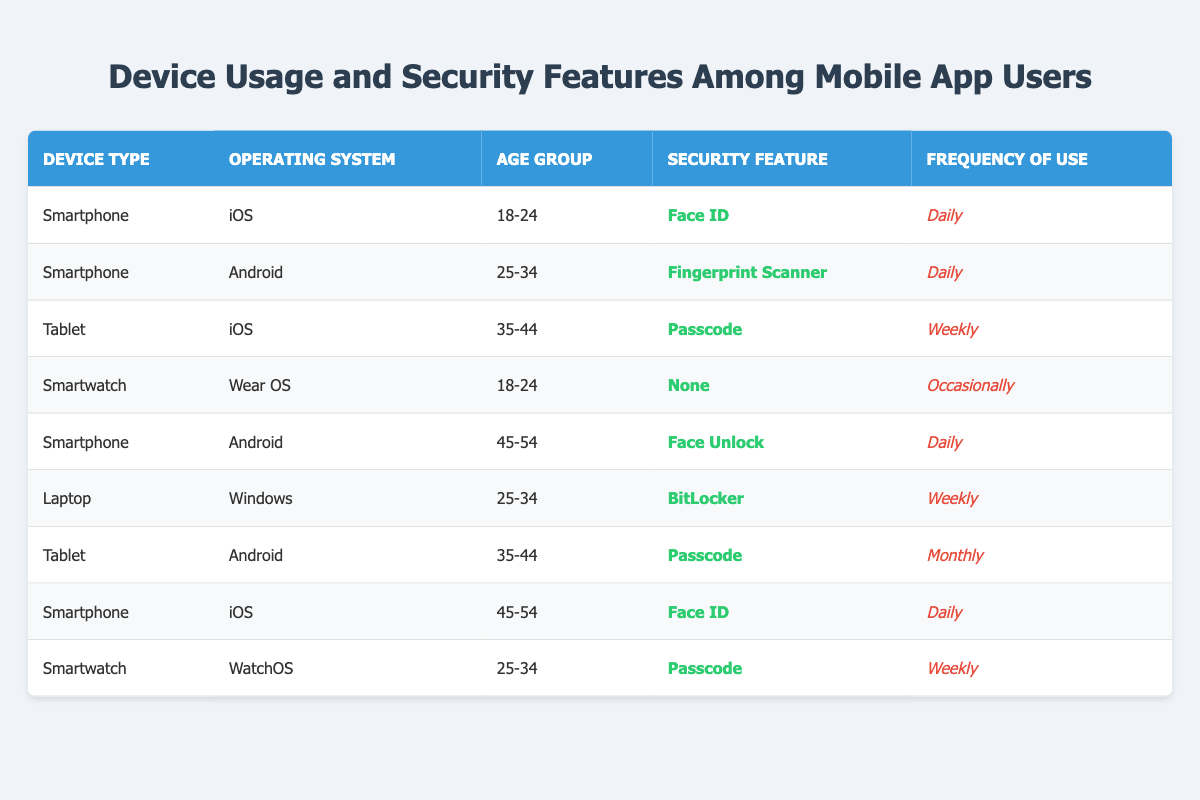What security feature is used by users aged 18-24 with smartphones running iOS? The table shows that in the row where the device type is "Smartphone," operating system is "iOS," and age group is "18-24," the security feature used is "Face ID."
Answer: Face ID How frequently do users aged 35-44 with tablets running iOS utilize the security feature? In the table, the row indicates that users with a tablet running iOS and aged 35-44 use the security feature "Passcode" with a frequency of "Weekly."
Answer: Weekly True or False: All users of smartwatches utilize a security feature. The table shows two entries for smartwatches: one user uses "None" and another uses "Passcode." This indicates at least one user does not utilize a security feature, therefore the statement is false.
Answer: False What percentage of smartphone users aged 45-54 use "Face ID"? There are two entries for smartphone users aged 45-54 in the table. Both of them use "Face ID". To find the percentage: (2 / 2) * 100 = 100%.
Answer: 100% Which operating system has the highest frequency of "Daily" use among smartphone users? By looking at the smartphone entries, we see two entries with "Daily" frequency: one for iOS using "Face ID" and one for Android using "Face Unlock." Since they both are smartphone operating systems, it shows that both iOS and Android have daily usage frequency.
Answer: iOS and Android 